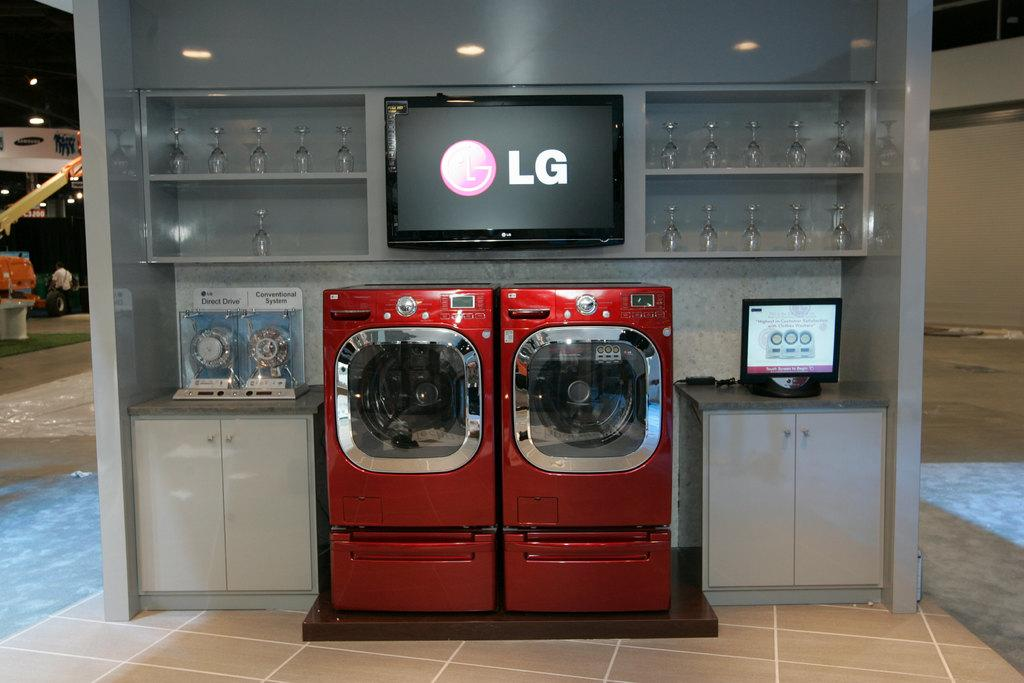<image>
Provide a brief description of the given image. A LG logo is on a television screen above a washer and dryer. 